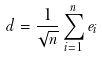<formula> <loc_0><loc_0><loc_500><loc_500>d = \frac { 1 } { \sqrt { n } } \sum _ { i = 1 } ^ { n } e _ { i }</formula> 